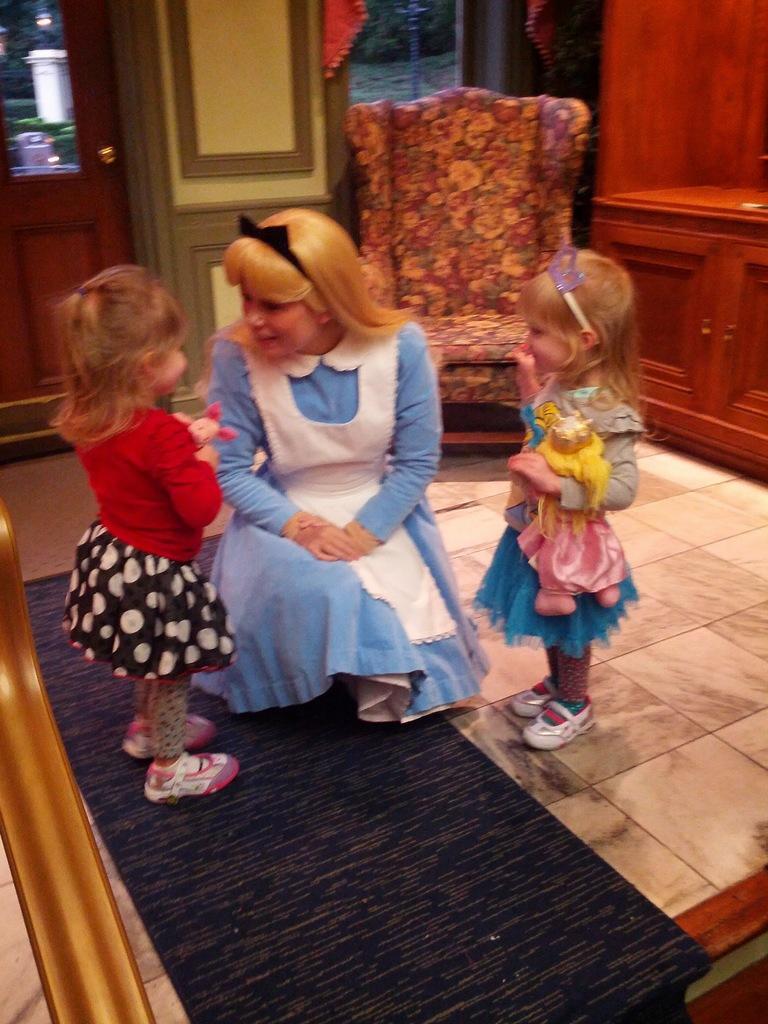Could you give a brief overview of what you see in this image? In this picture there is a mother wearing blue color dress is sitting on the ground and talking with two small girls. Behind there is a wooden wardrobe. On the left corner side there is a wooden door. 